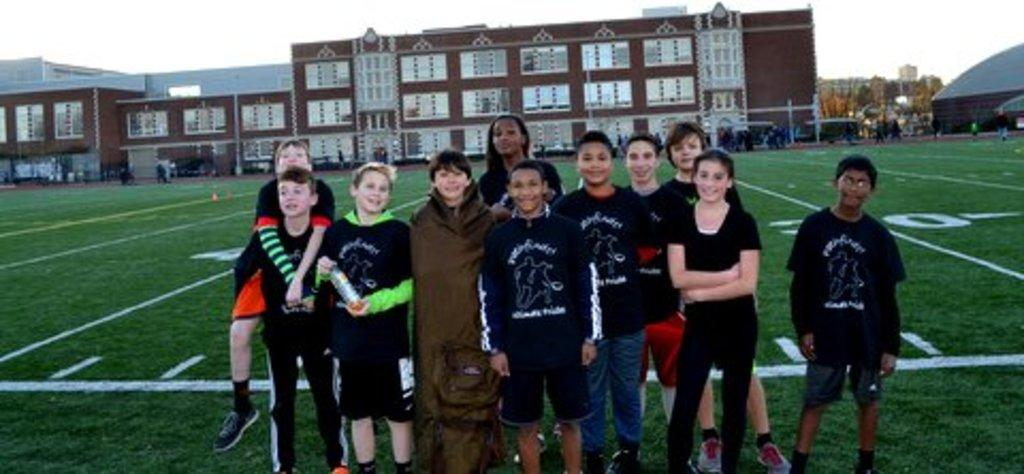What is the main subject of the image? The main subject of the image is kids standing. Where are the kids standing? The kids are standing on the ground. What can be seen on the ground? There are markings on the ground and grass. What is visible in the background of the image? There are buildings visible in the background. What is visible at the top of the image? The sky is visible at the top of the image. What type of crack is visible on the street in the image? There is no street present in the image, only grass on the ground. 